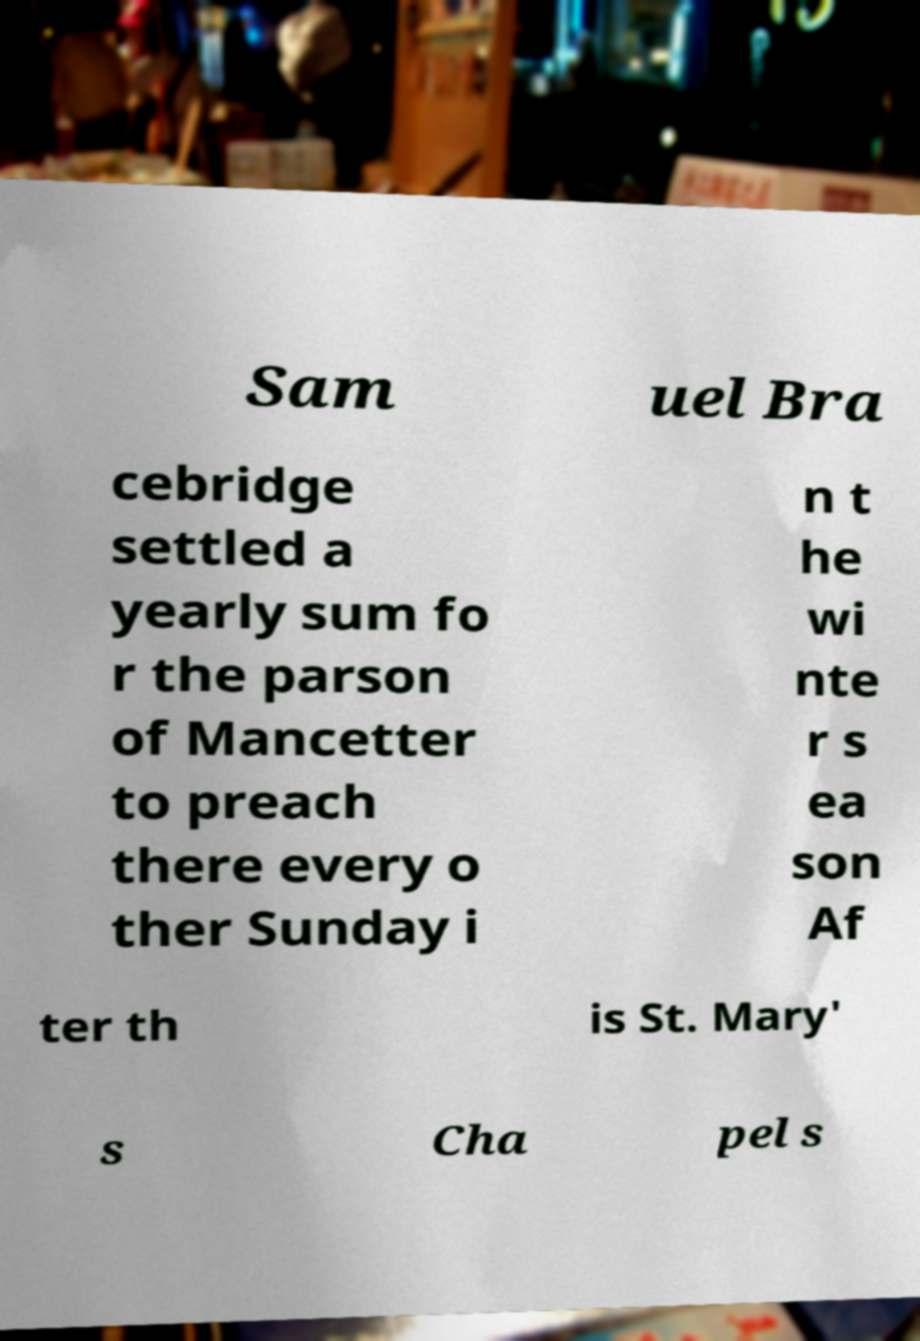What messages or text are displayed in this image? I need them in a readable, typed format. Sam uel Bra cebridge settled a yearly sum fo r the parson of Mancetter to preach there every o ther Sunday i n t he wi nte r s ea son Af ter th is St. Mary' s Cha pel s 